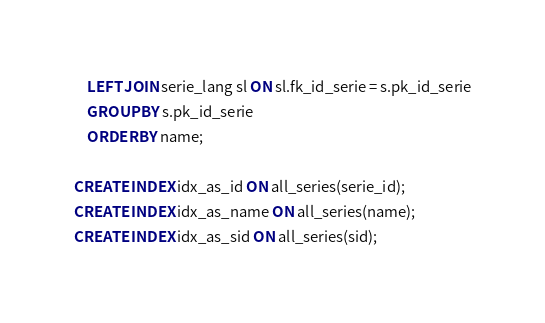Convert code to text. <code><loc_0><loc_0><loc_500><loc_500><_SQL_>	LEFT JOIN serie_lang sl ON sl.fk_id_serie = s.pk_id_serie
	GROUP BY s.pk_id_serie
    ORDER BY name;

CREATE INDEX idx_as_id ON all_series(serie_id);
CREATE INDEX idx_as_name ON all_series(name);
CREATE INDEX idx_as_sid ON all_series(sid);
</code> 